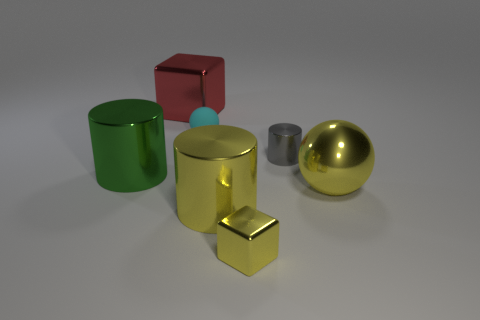Are there any other things that are the same material as the cyan object?
Make the answer very short. No. The other tiny object that is made of the same material as the gray thing is what color?
Give a very brief answer. Yellow. Are there an equal number of small cyan things that are in front of the tiny gray object and gray things?
Provide a succinct answer. No. The green shiny object that is the same size as the yellow metallic ball is what shape?
Keep it short and to the point. Cylinder. What number of other things are the same shape as the small matte object?
Give a very brief answer. 1. Is the size of the metallic sphere the same as the cylinder that is on the right side of the yellow cube?
Provide a short and direct response. No. How many things are balls that are behind the large green metallic cylinder or tiny balls?
Offer a very short reply. 1. There is a tiny metallic thing in front of the tiny gray metallic object; what shape is it?
Make the answer very short. Cube. Are there an equal number of tiny metallic things that are on the right side of the small yellow metallic cube and cylinders that are behind the red metallic object?
Make the answer very short. No. What is the color of the metal object that is in front of the red metallic block and behind the big green cylinder?
Keep it short and to the point. Gray. 